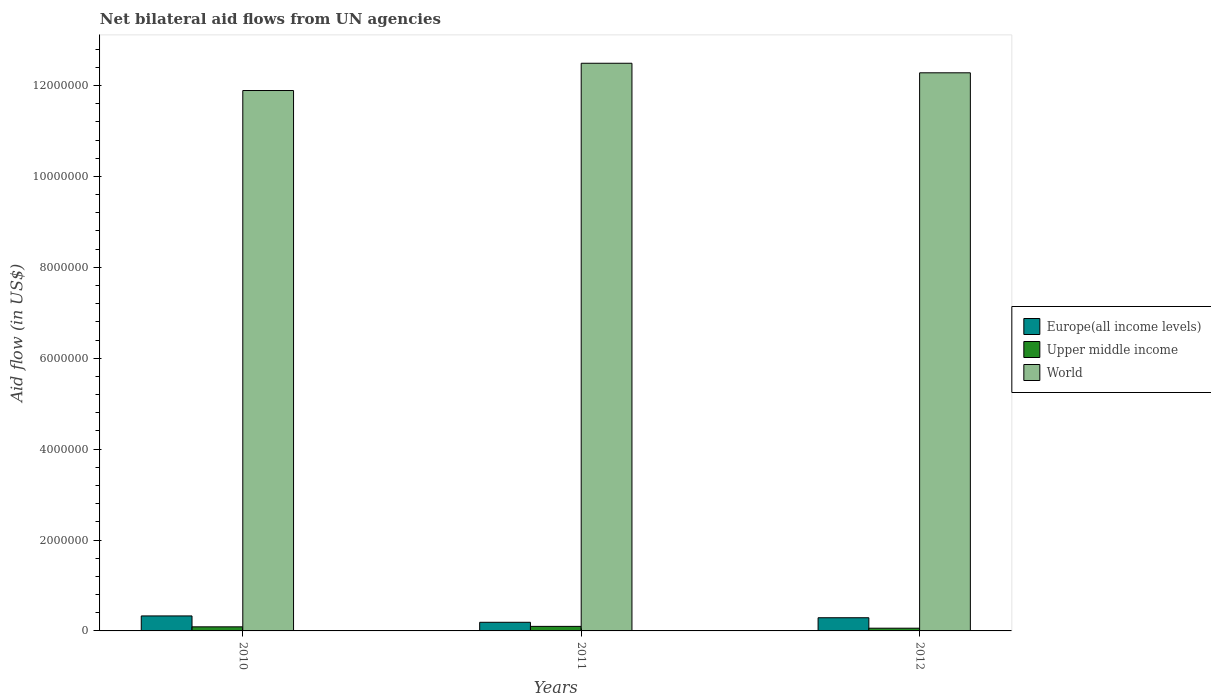How many groups of bars are there?
Your answer should be compact. 3. Are the number of bars per tick equal to the number of legend labels?
Your answer should be very brief. Yes. How many bars are there on the 2nd tick from the left?
Your response must be concise. 3. What is the net bilateral aid flow in World in 2010?
Keep it short and to the point. 1.19e+07. Across all years, what is the maximum net bilateral aid flow in Europe(all income levels)?
Your answer should be very brief. 3.30e+05. Across all years, what is the minimum net bilateral aid flow in Upper middle income?
Provide a succinct answer. 6.00e+04. What is the total net bilateral aid flow in World in the graph?
Your answer should be compact. 3.67e+07. What is the difference between the net bilateral aid flow in World in 2010 and that in 2011?
Your answer should be very brief. -6.00e+05. What is the difference between the net bilateral aid flow in Upper middle income in 2011 and the net bilateral aid flow in Europe(all income levels) in 2012?
Your answer should be compact. -1.90e+05. What is the average net bilateral aid flow in Europe(all income levels) per year?
Keep it short and to the point. 2.70e+05. In the year 2012, what is the difference between the net bilateral aid flow in World and net bilateral aid flow in Europe(all income levels)?
Provide a short and direct response. 1.20e+07. In how many years, is the net bilateral aid flow in Europe(all income levels) greater than 6000000 US$?
Ensure brevity in your answer.  0. What is the ratio of the net bilateral aid flow in Europe(all income levels) in 2010 to that in 2011?
Your answer should be very brief. 1.74. What is the difference between the highest and the second highest net bilateral aid flow in Europe(all income levels)?
Give a very brief answer. 4.00e+04. What is the difference between the highest and the lowest net bilateral aid flow in Europe(all income levels)?
Offer a very short reply. 1.40e+05. Is the sum of the net bilateral aid flow in World in 2011 and 2012 greater than the maximum net bilateral aid flow in Europe(all income levels) across all years?
Ensure brevity in your answer.  Yes. What does the 1st bar from the left in 2011 represents?
Provide a succinct answer. Europe(all income levels). What does the 3rd bar from the right in 2010 represents?
Keep it short and to the point. Europe(all income levels). How many years are there in the graph?
Your answer should be compact. 3. What is the difference between two consecutive major ticks on the Y-axis?
Your answer should be compact. 2.00e+06. Are the values on the major ticks of Y-axis written in scientific E-notation?
Ensure brevity in your answer.  No. Does the graph contain grids?
Provide a succinct answer. No. Where does the legend appear in the graph?
Keep it short and to the point. Center right. How many legend labels are there?
Your answer should be compact. 3. How are the legend labels stacked?
Your answer should be very brief. Vertical. What is the title of the graph?
Your answer should be compact. Net bilateral aid flows from UN agencies. Does "Channel Islands" appear as one of the legend labels in the graph?
Give a very brief answer. No. What is the label or title of the X-axis?
Your answer should be very brief. Years. What is the label or title of the Y-axis?
Keep it short and to the point. Aid flow (in US$). What is the Aid flow (in US$) in World in 2010?
Offer a very short reply. 1.19e+07. What is the Aid flow (in US$) in Europe(all income levels) in 2011?
Offer a terse response. 1.90e+05. What is the Aid flow (in US$) of World in 2011?
Give a very brief answer. 1.25e+07. What is the Aid flow (in US$) of Europe(all income levels) in 2012?
Provide a short and direct response. 2.90e+05. What is the Aid flow (in US$) of World in 2012?
Your answer should be compact. 1.23e+07. Across all years, what is the maximum Aid flow (in US$) of Europe(all income levels)?
Make the answer very short. 3.30e+05. Across all years, what is the maximum Aid flow (in US$) of Upper middle income?
Ensure brevity in your answer.  1.00e+05. Across all years, what is the maximum Aid flow (in US$) of World?
Your answer should be compact. 1.25e+07. Across all years, what is the minimum Aid flow (in US$) in Europe(all income levels)?
Ensure brevity in your answer.  1.90e+05. Across all years, what is the minimum Aid flow (in US$) in Upper middle income?
Ensure brevity in your answer.  6.00e+04. Across all years, what is the minimum Aid flow (in US$) in World?
Provide a short and direct response. 1.19e+07. What is the total Aid flow (in US$) in Europe(all income levels) in the graph?
Ensure brevity in your answer.  8.10e+05. What is the total Aid flow (in US$) in World in the graph?
Give a very brief answer. 3.67e+07. What is the difference between the Aid flow (in US$) of World in 2010 and that in 2011?
Keep it short and to the point. -6.00e+05. What is the difference between the Aid flow (in US$) of Europe(all income levels) in 2010 and that in 2012?
Give a very brief answer. 4.00e+04. What is the difference between the Aid flow (in US$) of World in 2010 and that in 2012?
Offer a terse response. -3.90e+05. What is the difference between the Aid flow (in US$) in Upper middle income in 2011 and that in 2012?
Your answer should be very brief. 4.00e+04. What is the difference between the Aid flow (in US$) in Europe(all income levels) in 2010 and the Aid flow (in US$) in Upper middle income in 2011?
Ensure brevity in your answer.  2.30e+05. What is the difference between the Aid flow (in US$) in Europe(all income levels) in 2010 and the Aid flow (in US$) in World in 2011?
Provide a short and direct response. -1.22e+07. What is the difference between the Aid flow (in US$) in Upper middle income in 2010 and the Aid flow (in US$) in World in 2011?
Provide a short and direct response. -1.24e+07. What is the difference between the Aid flow (in US$) in Europe(all income levels) in 2010 and the Aid flow (in US$) in World in 2012?
Your answer should be compact. -1.20e+07. What is the difference between the Aid flow (in US$) of Upper middle income in 2010 and the Aid flow (in US$) of World in 2012?
Your answer should be very brief. -1.22e+07. What is the difference between the Aid flow (in US$) of Europe(all income levels) in 2011 and the Aid flow (in US$) of Upper middle income in 2012?
Make the answer very short. 1.30e+05. What is the difference between the Aid flow (in US$) in Europe(all income levels) in 2011 and the Aid flow (in US$) in World in 2012?
Your answer should be very brief. -1.21e+07. What is the difference between the Aid flow (in US$) of Upper middle income in 2011 and the Aid flow (in US$) of World in 2012?
Offer a very short reply. -1.22e+07. What is the average Aid flow (in US$) of Europe(all income levels) per year?
Your response must be concise. 2.70e+05. What is the average Aid flow (in US$) in Upper middle income per year?
Your response must be concise. 8.33e+04. What is the average Aid flow (in US$) in World per year?
Give a very brief answer. 1.22e+07. In the year 2010, what is the difference between the Aid flow (in US$) of Europe(all income levels) and Aid flow (in US$) of World?
Provide a succinct answer. -1.16e+07. In the year 2010, what is the difference between the Aid flow (in US$) of Upper middle income and Aid flow (in US$) of World?
Offer a terse response. -1.18e+07. In the year 2011, what is the difference between the Aid flow (in US$) in Europe(all income levels) and Aid flow (in US$) in Upper middle income?
Your response must be concise. 9.00e+04. In the year 2011, what is the difference between the Aid flow (in US$) of Europe(all income levels) and Aid flow (in US$) of World?
Provide a succinct answer. -1.23e+07. In the year 2011, what is the difference between the Aid flow (in US$) of Upper middle income and Aid flow (in US$) of World?
Provide a succinct answer. -1.24e+07. In the year 2012, what is the difference between the Aid flow (in US$) in Europe(all income levels) and Aid flow (in US$) in World?
Provide a short and direct response. -1.20e+07. In the year 2012, what is the difference between the Aid flow (in US$) in Upper middle income and Aid flow (in US$) in World?
Keep it short and to the point. -1.22e+07. What is the ratio of the Aid flow (in US$) in Europe(all income levels) in 2010 to that in 2011?
Keep it short and to the point. 1.74. What is the ratio of the Aid flow (in US$) of World in 2010 to that in 2011?
Your answer should be very brief. 0.95. What is the ratio of the Aid flow (in US$) of Europe(all income levels) in 2010 to that in 2012?
Keep it short and to the point. 1.14. What is the ratio of the Aid flow (in US$) of Upper middle income in 2010 to that in 2012?
Ensure brevity in your answer.  1.5. What is the ratio of the Aid flow (in US$) of World in 2010 to that in 2012?
Provide a succinct answer. 0.97. What is the ratio of the Aid flow (in US$) in Europe(all income levels) in 2011 to that in 2012?
Ensure brevity in your answer.  0.66. What is the ratio of the Aid flow (in US$) in Upper middle income in 2011 to that in 2012?
Ensure brevity in your answer.  1.67. What is the ratio of the Aid flow (in US$) of World in 2011 to that in 2012?
Your answer should be very brief. 1.02. What is the difference between the highest and the second highest Aid flow (in US$) in Upper middle income?
Give a very brief answer. 10000. What is the difference between the highest and the second highest Aid flow (in US$) in World?
Your response must be concise. 2.10e+05. What is the difference between the highest and the lowest Aid flow (in US$) in Europe(all income levels)?
Your answer should be very brief. 1.40e+05. What is the difference between the highest and the lowest Aid flow (in US$) of Upper middle income?
Provide a short and direct response. 4.00e+04. 